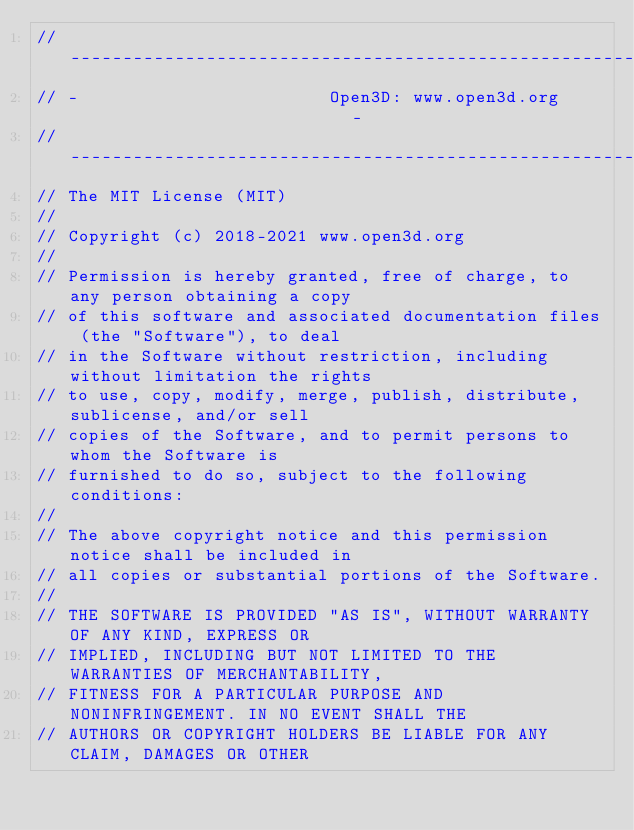Convert code to text. <code><loc_0><loc_0><loc_500><loc_500><_Cuda_>// ----------------------------------------------------------------------------
// -                        Open3D: www.open3d.org                            -
// ----------------------------------------------------------------------------
// The MIT License (MIT)
//
// Copyright (c) 2018-2021 www.open3d.org
//
// Permission is hereby granted, free of charge, to any person obtaining a copy
// of this software and associated documentation files (the "Software"), to deal
// in the Software without restriction, including without limitation the rights
// to use, copy, modify, merge, publish, distribute, sublicense, and/or sell
// copies of the Software, and to permit persons to whom the Software is
// furnished to do so, subject to the following conditions:
//
// The above copyright notice and this permission notice shall be included in
// all copies or substantial portions of the Software.
//
// THE SOFTWARE IS PROVIDED "AS IS", WITHOUT WARRANTY OF ANY KIND, EXPRESS OR
// IMPLIED, INCLUDING BUT NOT LIMITED TO THE WARRANTIES OF MERCHANTABILITY,
// FITNESS FOR A PARTICULAR PURPOSE AND NONINFRINGEMENT. IN NO EVENT SHALL THE
// AUTHORS OR COPYRIGHT HOLDERS BE LIABLE FOR ANY CLAIM, DAMAGES OR OTHER</code> 